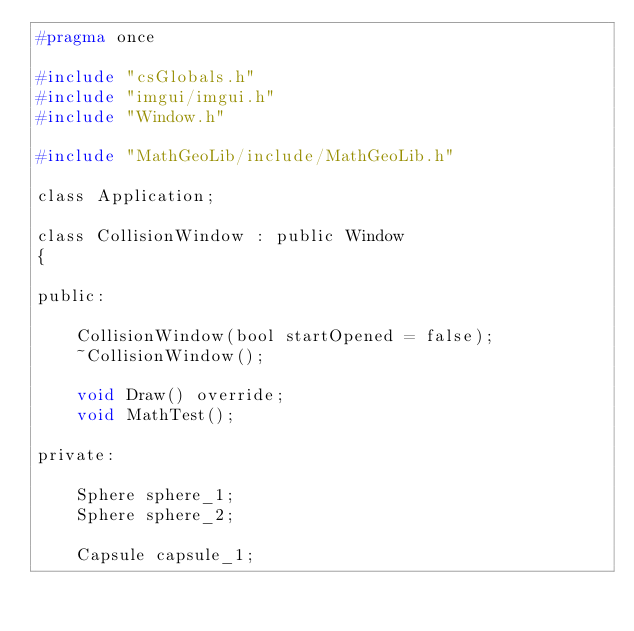Convert code to text. <code><loc_0><loc_0><loc_500><loc_500><_C_>#pragma once

#include "csGlobals.h"
#include "imgui/imgui.h"
#include "Window.h"

#include "MathGeoLib/include/MathGeoLib.h"

class Application;

class CollisionWindow : public Window
{

public:

	CollisionWindow(bool startOpened = false);
	~CollisionWindow();

	void Draw() override;
	void MathTest();

private:

	Sphere sphere_1;
	Sphere sphere_2;

	Capsule capsule_1;</code> 